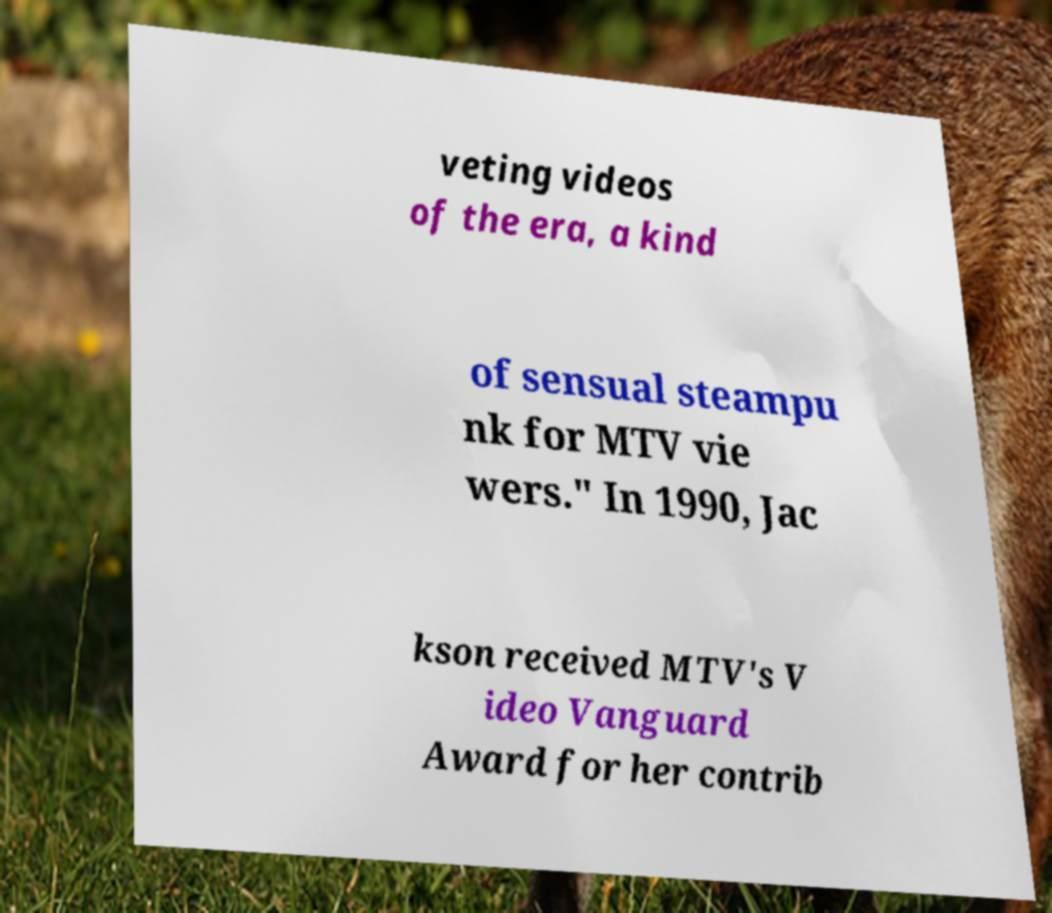I need the written content from this picture converted into text. Can you do that? veting videos of the era, a kind of sensual steampu nk for MTV vie wers." In 1990, Jac kson received MTV's V ideo Vanguard Award for her contrib 